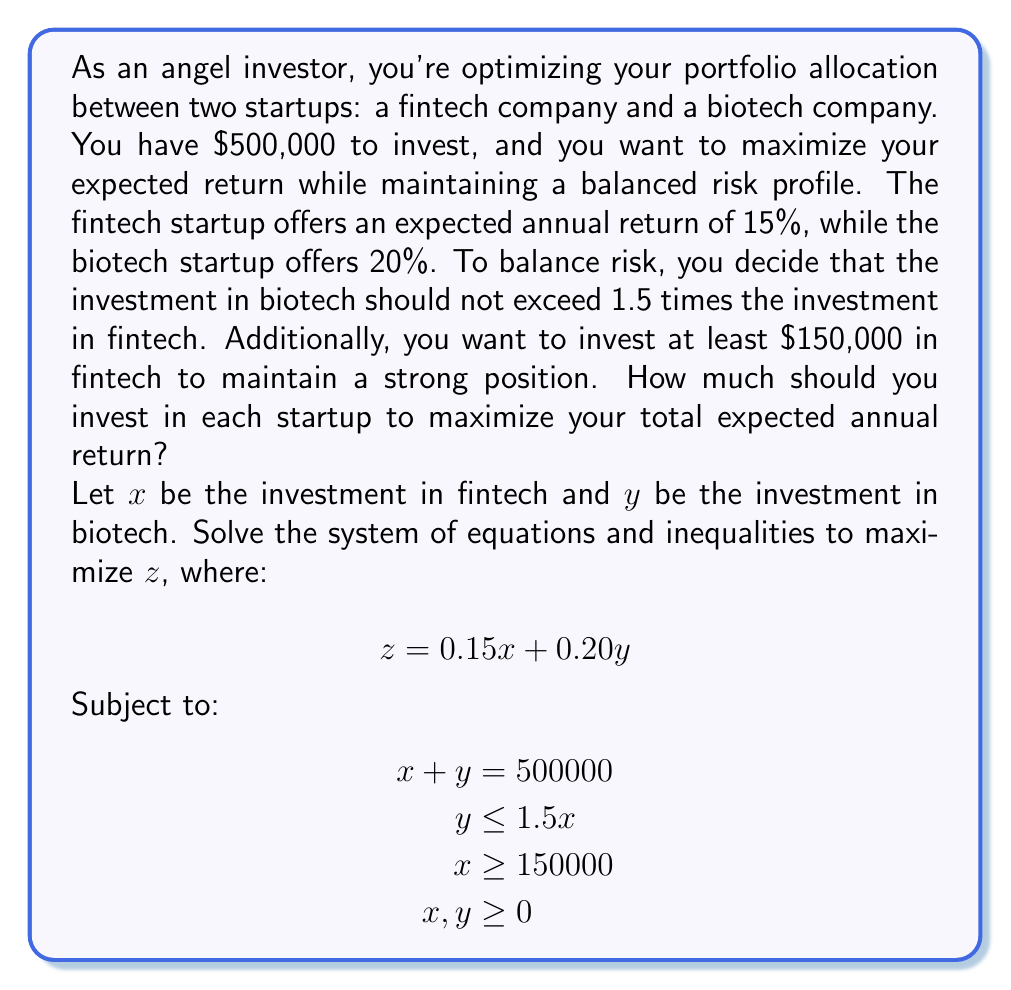Help me with this question. Let's solve this step-by-step:

1) First, we need to identify the binding constraints. The constraint $y \leq 1.5x$ will be binding at the optimal solution because it allows us to invest more in the higher-return biotech startup.

2) At the optimal point, we'll have:
   $$y = 1.5x$$

3) Substituting this into the total investment constraint:
   $$x + 1.5x = 500000$$
   $$2.5x = 500000$$
   $$x = 200000$$

4) Now we can calculate y:
   $$y = 1.5 * 200000 = 300000$$

5) Let's verify that this solution satisfies all constraints:
   - $x + y = 200000 + 300000 = 500000$ (satisfies total investment constraint)
   - $y = 300000 \leq 1.5 * 200000 = 300000$ (satisfies risk balance constraint)
   - $x = 200000 \geq 150000$ (satisfies minimum fintech investment constraint)
   - Both $x$ and $y$ are non-negative

6) The maximum expected return is:
   $$z = 0.15 * 200000 + 0.20 * 300000 = 30000 + 60000 = 90000$$

Therefore, to maximize the expected annual return, you should invest $200,000 in the fintech startup and $300,000 in the biotech startup, yielding an expected annual return of $90,000 or 18% of the total investment.
Answer: Fintech: $200,000; Biotech: $300,000 